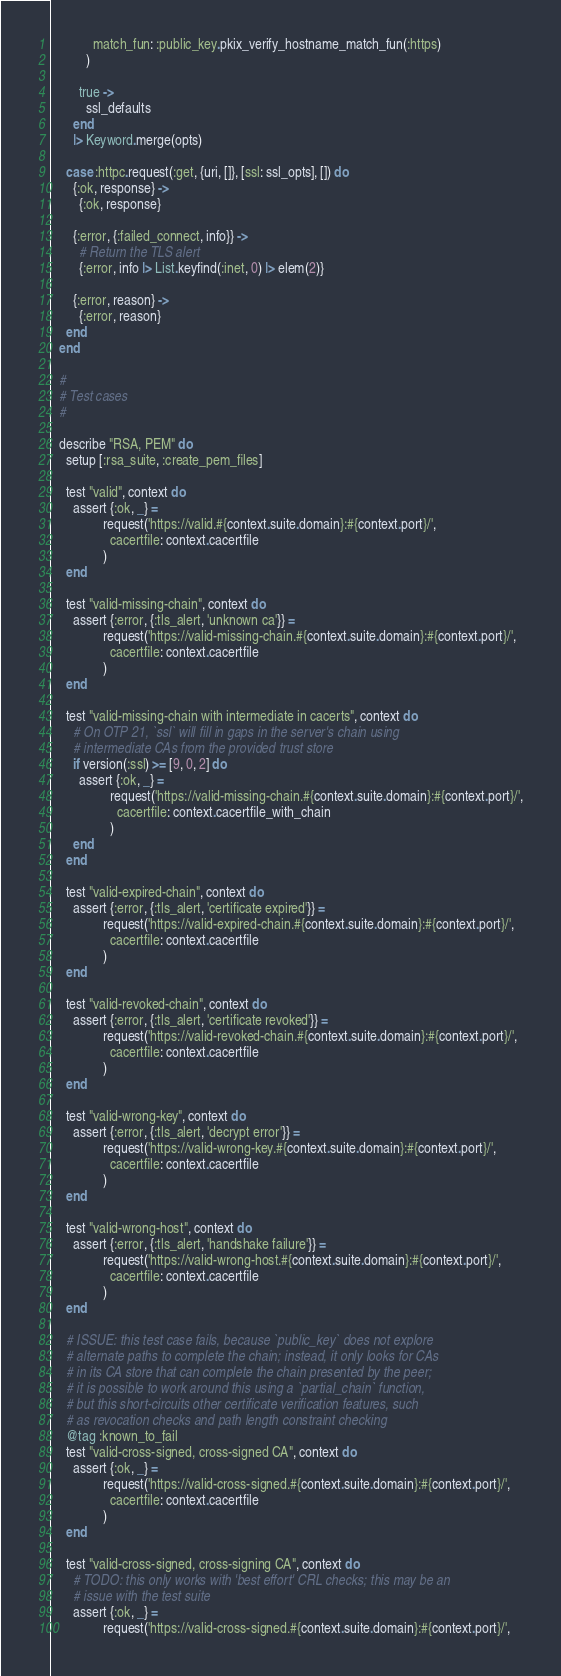Convert code to text. <code><loc_0><loc_0><loc_500><loc_500><_Elixir_>            match_fun: :public_key.pkix_verify_hostname_match_fun(:https)
          )

        true ->
          ssl_defaults
      end
      |> Keyword.merge(opts)

    case :httpc.request(:get, {uri, []}, [ssl: ssl_opts], []) do
      {:ok, response} ->
        {:ok, response}

      {:error, {:failed_connect, info}} ->
        # Return the TLS alert
        {:error, info |> List.keyfind(:inet, 0) |> elem(2)}

      {:error, reason} ->
        {:error, reason}
    end
  end

  #
  # Test cases
  #

  describe "RSA, PEM" do
    setup [:rsa_suite, :create_pem_files]

    test "valid", context do
      assert {:ok, _} =
               request('https://valid.#{context.suite.domain}:#{context.port}/',
                 cacertfile: context.cacertfile
               )
    end

    test "valid-missing-chain", context do
      assert {:error, {:tls_alert, 'unknown ca'}} =
               request('https://valid-missing-chain.#{context.suite.domain}:#{context.port}/',
                 cacertfile: context.cacertfile
               )
    end

    test "valid-missing-chain with intermediate in cacerts", context do
      # On OTP 21, `ssl` will fill in gaps in the server's chain using
      # intermediate CAs from the provided trust store
      if version(:ssl) >= [9, 0, 2] do
        assert {:ok, _} =
                 request('https://valid-missing-chain.#{context.suite.domain}:#{context.port}/',
                   cacertfile: context.cacertfile_with_chain
                 )
      end
    end

    test "valid-expired-chain", context do
      assert {:error, {:tls_alert, 'certificate expired'}} =
               request('https://valid-expired-chain.#{context.suite.domain}:#{context.port}/',
                 cacertfile: context.cacertfile
               )
    end

    test "valid-revoked-chain", context do
      assert {:error, {:tls_alert, 'certificate revoked'}} =
               request('https://valid-revoked-chain.#{context.suite.domain}:#{context.port}/',
                 cacertfile: context.cacertfile
               )
    end

    test "valid-wrong-key", context do
      assert {:error, {:tls_alert, 'decrypt error'}} =
               request('https://valid-wrong-key.#{context.suite.domain}:#{context.port}/',
                 cacertfile: context.cacertfile
               )
    end

    test "valid-wrong-host", context do
      assert {:error, {:tls_alert, 'handshake failure'}} =
               request('https://valid-wrong-host.#{context.suite.domain}:#{context.port}/',
                 cacertfile: context.cacertfile
               )
    end

    # ISSUE: this test case fails, because `public_key` does not explore
    # alternate paths to complete the chain; instead, it only looks for CAs
    # in its CA store that can complete the chain presented by the peer;
    # it is possible to work around this using a `partial_chain` function,
    # but this short-circuits other certificate verification features, such
    # as revocation checks and path length constraint checking
    @tag :known_to_fail
    test "valid-cross-signed, cross-signed CA", context do
      assert {:ok, _} =
               request('https://valid-cross-signed.#{context.suite.domain}:#{context.port}/',
                 cacertfile: context.cacertfile
               )
    end

    test "valid-cross-signed, cross-signing CA", context do
      # TODO: this only works with 'best effort' CRL checks; this may be an
      # issue with the test suite
      assert {:ok, _} =
               request('https://valid-cross-signed.#{context.suite.domain}:#{context.port}/',</code> 